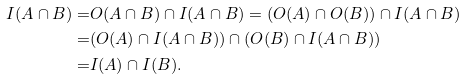<formula> <loc_0><loc_0><loc_500><loc_500>I ( A \cap B ) = & O ( A \cap B ) \cap I ( A \cap B ) = ( O ( A ) \cap O ( B ) ) \cap I ( A \cap B ) \\ = & ( O ( A ) \cap I ( A \cap B ) ) \cap ( O ( B ) \cap I ( A \cap B ) ) \\ = & I ( A ) \cap I ( B ) .</formula> 